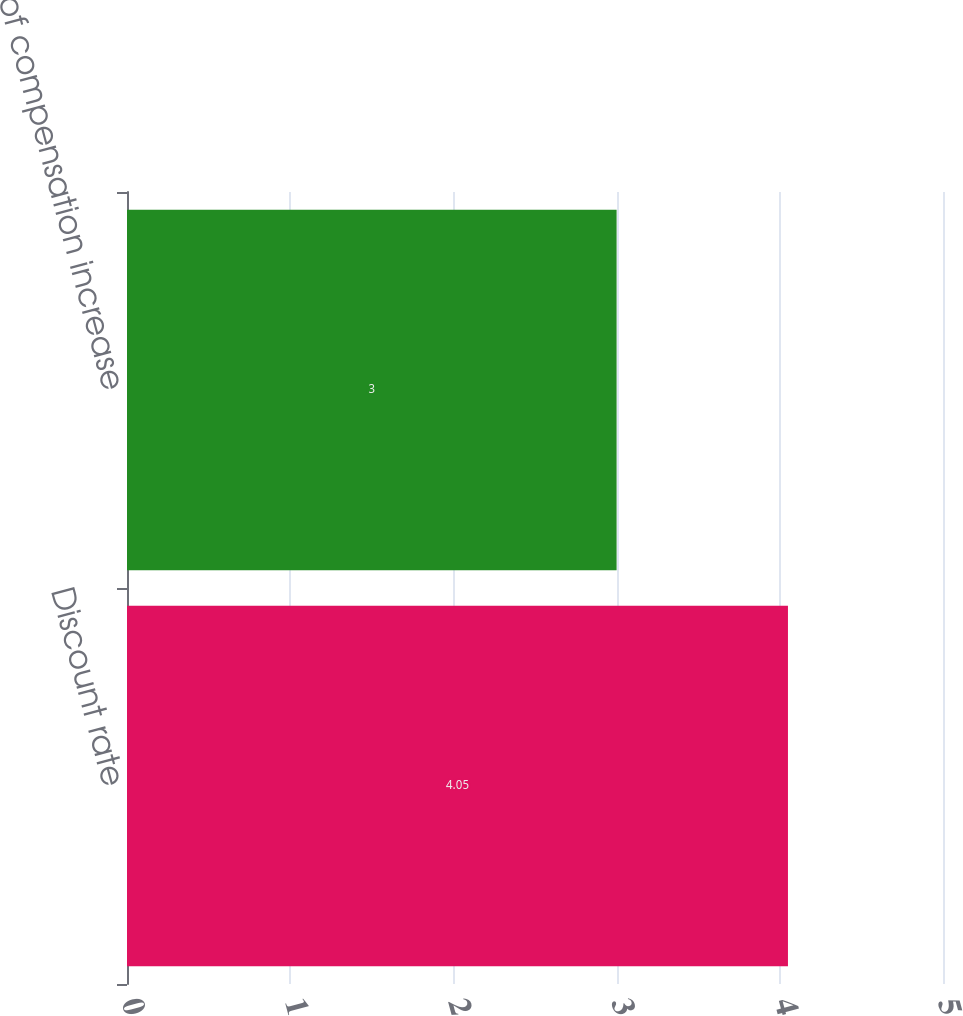Convert chart. <chart><loc_0><loc_0><loc_500><loc_500><bar_chart><fcel>Discount rate<fcel>Rate of compensation increase<nl><fcel>4.05<fcel>3<nl></chart> 